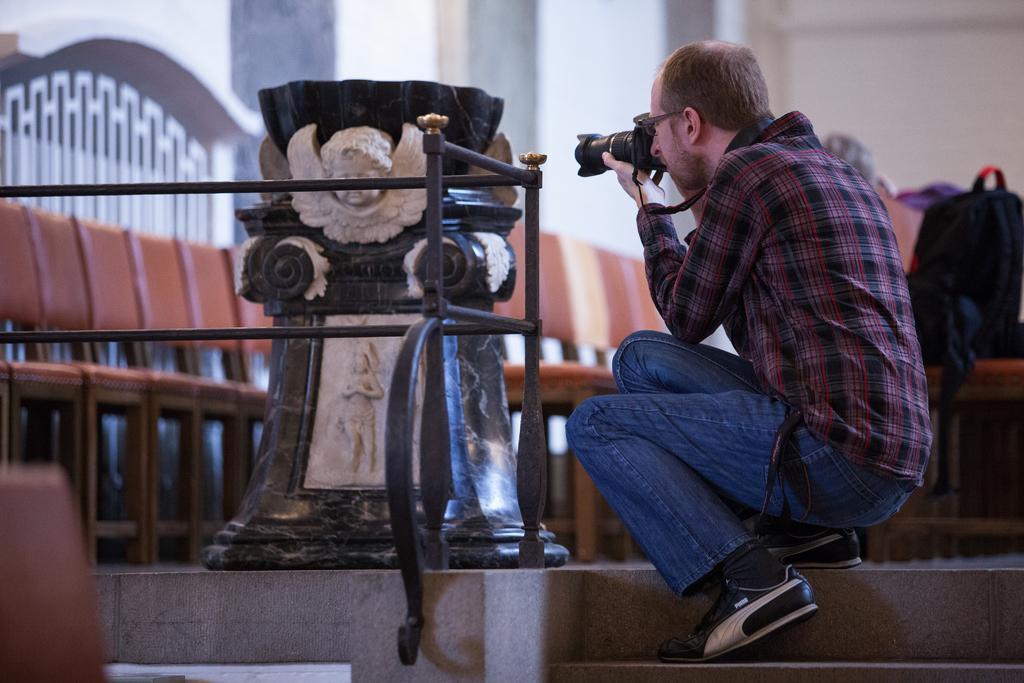How would you summarize this image in a sentence or two? On the right side of the image there is a person sitting on the steps holding camera. On the left side of the image we can see a statue. In the background we can see chairs, bag, and wall. 